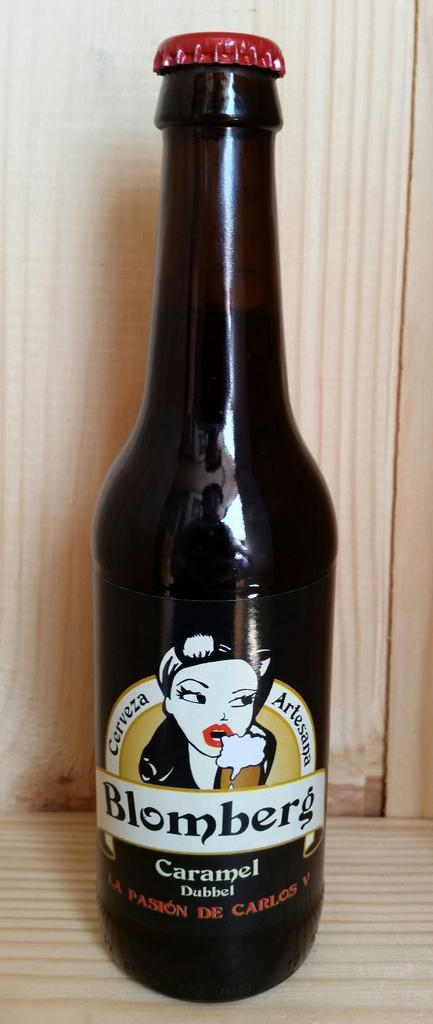<image>
Present a compact description of the photo's key features. A brown bottle of Blomberg Carmel Dubbel, a kind of beer 